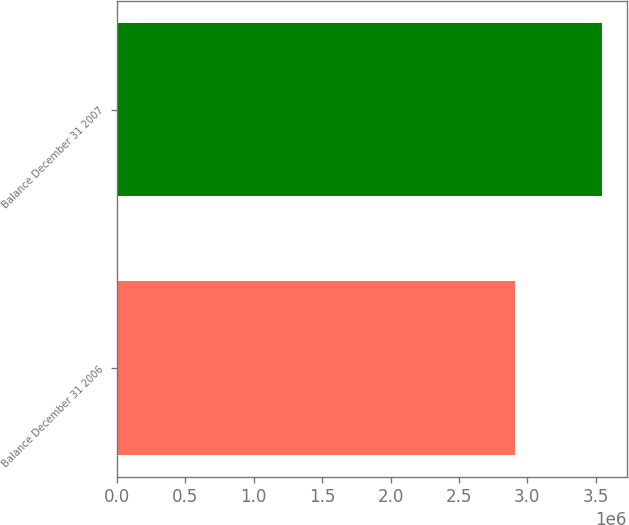Convert chart. <chart><loc_0><loc_0><loc_500><loc_500><bar_chart><fcel>Balance December 31 2006<fcel>Balance December 31 2007<nl><fcel>2.91179e+06<fcel>3.54924e+06<nl></chart> 